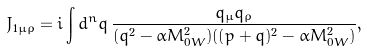Convert formula to latex. <formula><loc_0><loc_0><loc_500><loc_500>J _ { 1 \mu \rho } = i \int d ^ { n } q \, \frac { q _ { \mu } q _ { \rho } } { ( q ^ { 2 } - \alpha M _ { 0 W } ^ { 2 } ) ( ( p + q ) ^ { 2 } - \alpha M _ { 0 W } ^ { 2 } ) } ,</formula> 